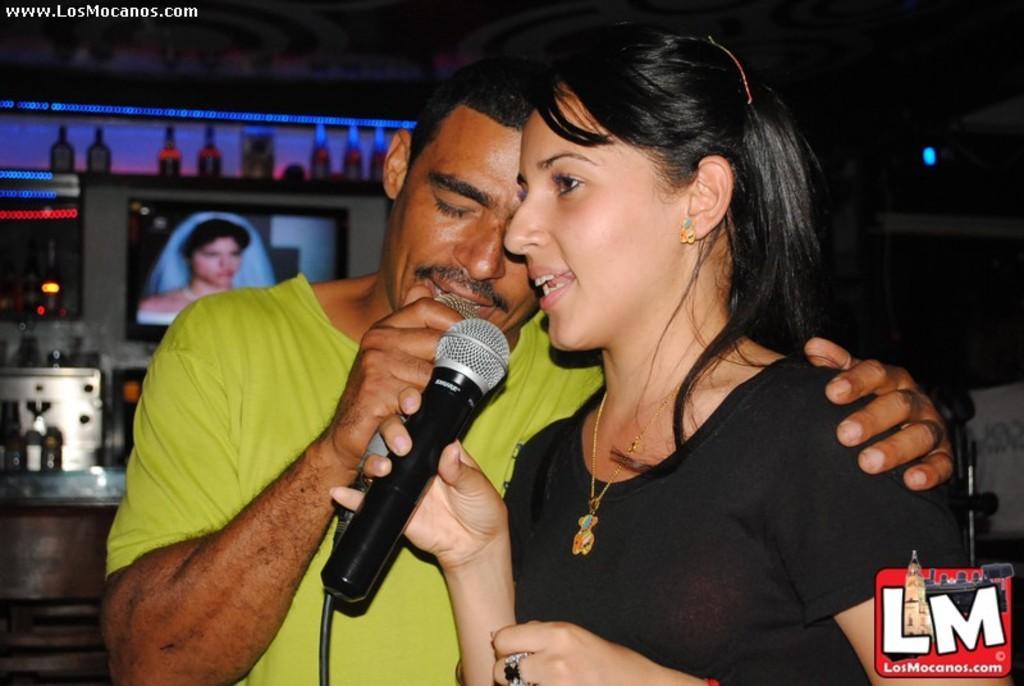Describe this image in one or two sentences. In this picture we can see a man and woman, they are holding microphones, in the background we can see screens, lights and bottles, in the top left hand corner we can see some text, in the bottom right hand corner we can see a logo. 